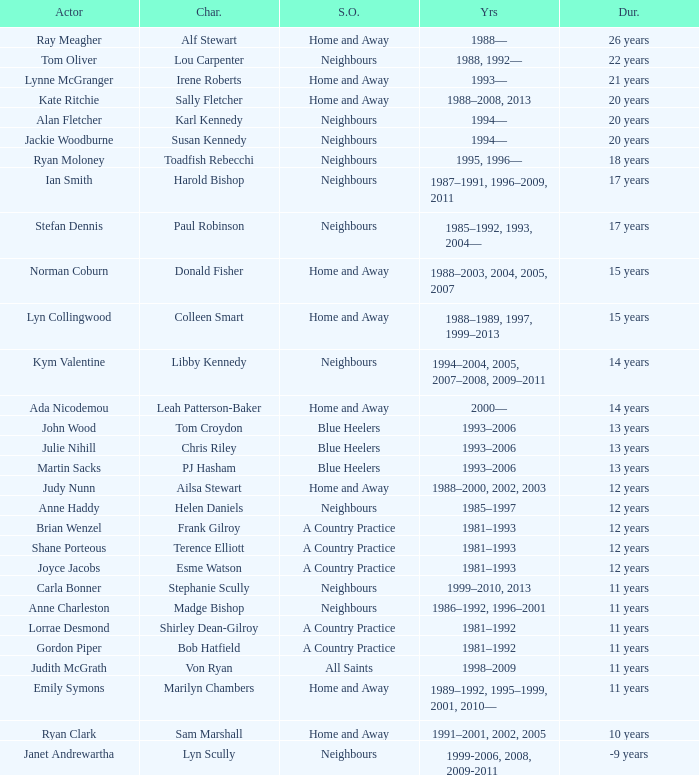Which actor played on Home and Away for 20 years? Kate Ritchie. 